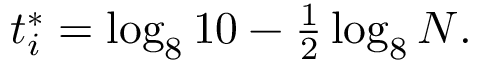Convert formula to latex. <formula><loc_0><loc_0><loc_500><loc_500>\begin{array} { r } { t _ { i } ^ { * } = \log _ { 8 } { 1 0 } - \frac { 1 } { 2 } \log _ { 8 } { N } . } \end{array}</formula> 